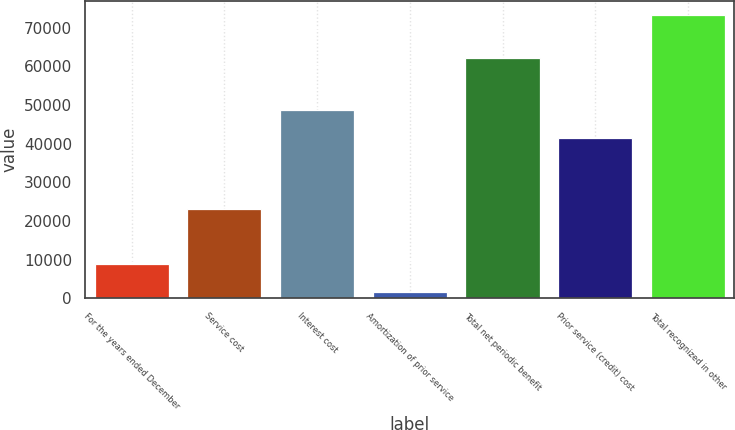<chart> <loc_0><loc_0><loc_500><loc_500><bar_chart><fcel>For the years ended December<fcel>Service cost<fcel>Interest cost<fcel>Amortization of prior service<fcel>Total net periodic benefit<fcel>Prior service (credit) cost<fcel>Total recognized in other<nl><fcel>8728.4<fcel>23075<fcel>48690.4<fcel>1555<fcel>62172<fcel>41517<fcel>73289<nl></chart> 